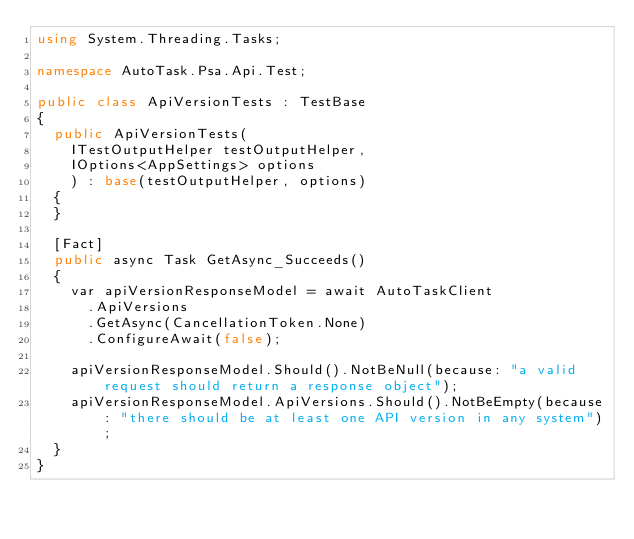<code> <loc_0><loc_0><loc_500><loc_500><_C#_>using System.Threading.Tasks;

namespace AutoTask.Psa.Api.Test;

public class ApiVersionTests : TestBase
{
	public ApiVersionTests(
		ITestOutputHelper testOutputHelper,
		IOptions<AppSettings> options
		) : base(testOutputHelper, options)
	{
	}

	[Fact]
	public async Task GetAsync_Succeeds()
	{
		var apiVersionResponseModel = await AutoTaskClient
			.ApiVersions
			.GetAsync(CancellationToken.None)
			.ConfigureAwait(false);

		apiVersionResponseModel.Should().NotBeNull(because: "a valid request should return a response object");
		apiVersionResponseModel.ApiVersions.Should().NotBeEmpty(because: "there should be at least one API version in any system");
	}
}
</code> 